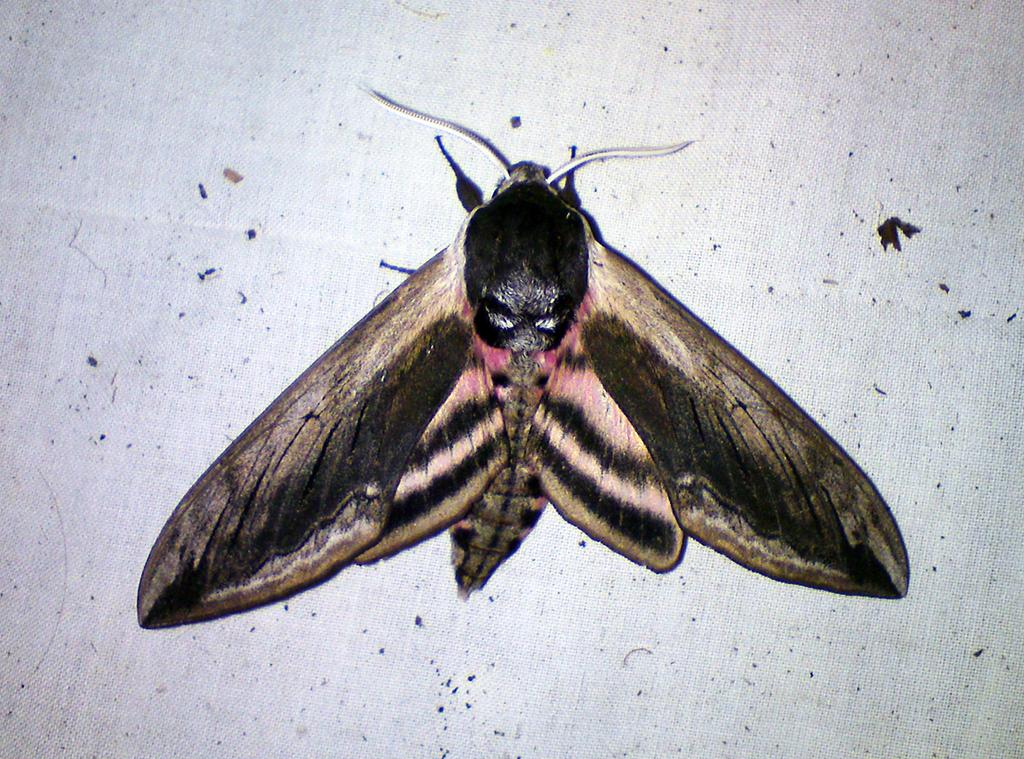What is the main subject in the center of the image? There is a fly in the center of the image. What color is the background of the image? The background of the image is white. What type of sugar is being used to sweeten the stew in the image? There is no stew or sugar present in the image; it features a fly in the center of a white background. How many pizzas are visible on the table in the image? There are no pizzas present in the image. 